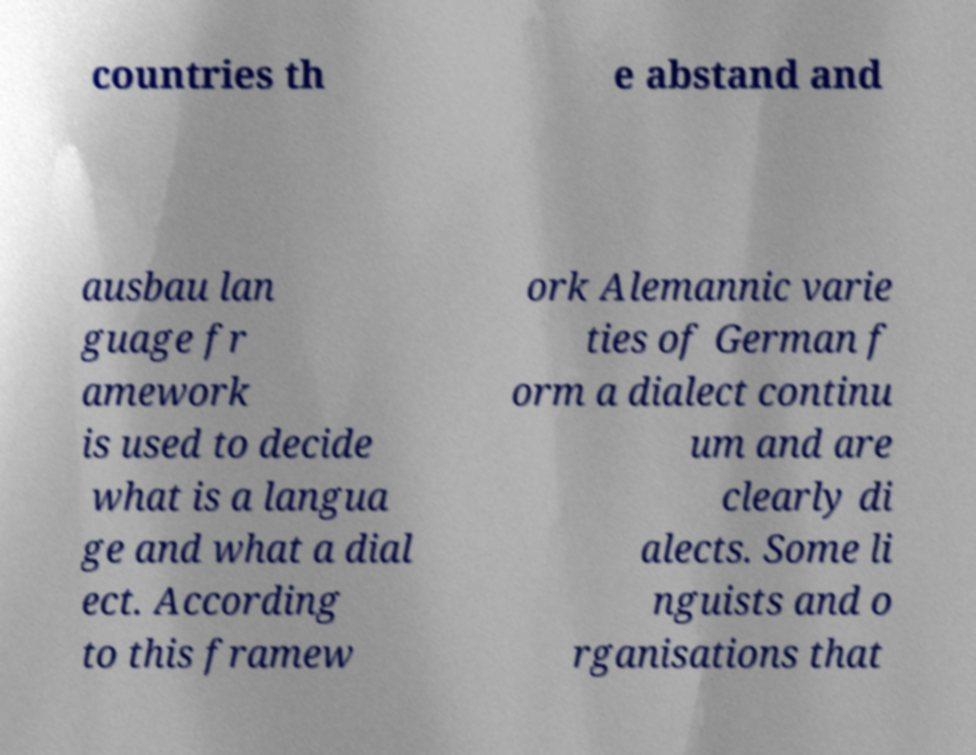What messages or text are displayed in this image? I need them in a readable, typed format. countries th e abstand and ausbau lan guage fr amework is used to decide what is a langua ge and what a dial ect. According to this framew ork Alemannic varie ties of German f orm a dialect continu um and are clearly di alects. Some li nguists and o rganisations that 